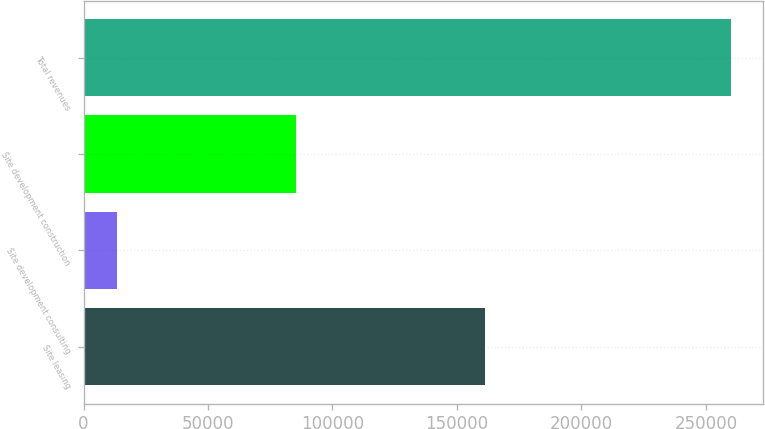Convert chart. <chart><loc_0><loc_0><loc_500><loc_500><bar_chart><fcel>Site leasing<fcel>Site development consulting<fcel>Site development construction<fcel>Total revenues<nl><fcel>161277<fcel>13549<fcel>85165<fcel>259991<nl></chart> 